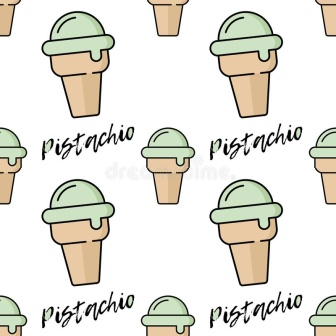Describe the scene depicted within the image. The image showcases a charming arrangement of pistachio ice cream cones. Each cone is colored in a soft light brown, supporting a delicious looking scoop of green pistachio ice cream. The cones are organized in a consistent pattern, forming four rows and three columns. Above and below each cone, the word 'Pistachio' is stylishly written in bold black text, emphasizing the flavor. This repetitive and orderly presentation creates a visually satisfying and appealing scene. 